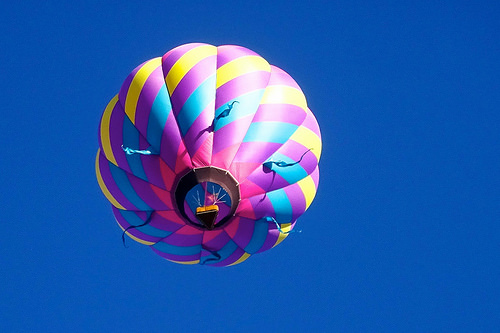<image>
Is the balloon on the sky? Yes. Looking at the image, I can see the balloon is positioned on top of the sky, with the sky providing support. 